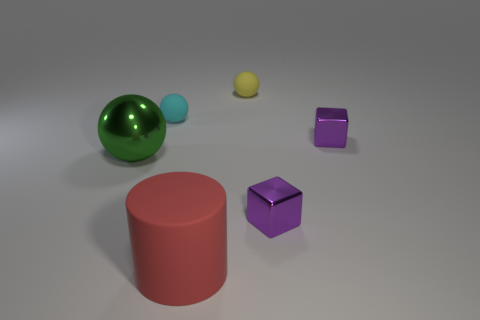How many objects are either purple blocks or things that are in front of the big green metal thing?
Offer a very short reply. 3. There is another small sphere that is the same material as the tiny cyan sphere; what is its color?
Offer a terse response. Yellow. How many tiny yellow objects have the same material as the cyan ball?
Offer a very short reply. 1. How many large red objects are there?
Ensure brevity in your answer.  1. Is the color of the small matte sphere in front of the yellow ball the same as the metal thing that is on the left side of the big red rubber cylinder?
Make the answer very short. No. How many purple shiny objects are behind the small yellow object?
Your answer should be compact. 0. Is there another tiny cyan object that has the same shape as the small cyan object?
Keep it short and to the point. No. Is the tiny sphere in front of the yellow object made of the same material as the red object in front of the tiny yellow sphere?
Give a very brief answer. Yes. What size is the purple metal object that is behind the big green ball on the left side of the matte sphere that is to the right of the cylinder?
Make the answer very short. Small. There is a object that is the same size as the rubber cylinder; what is its material?
Provide a succinct answer. Metal. 